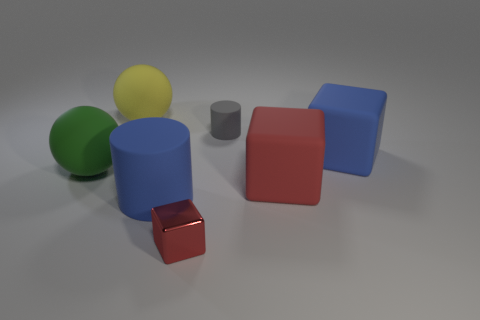Are there any blue matte objects that have the same shape as the tiny metal object?
Ensure brevity in your answer.  Yes. The yellow object that is the same size as the green thing is what shape?
Offer a very short reply. Sphere. What number of big matte cubes are the same color as the metal block?
Give a very brief answer. 1. How big is the blue object that is right of the blue cylinder?
Provide a short and direct response. Large. How many other objects have the same size as the gray object?
Your answer should be very brief. 1. What color is the tiny thing that is the same material as the large blue cube?
Your response must be concise. Gray. Are there fewer matte cylinders right of the big red cube than green cubes?
Provide a short and direct response. No. The red thing that is the same material as the big blue cylinder is what shape?
Your response must be concise. Cube. How many rubber things are red cubes or large gray cubes?
Provide a succinct answer. 1. Are there the same number of large blue things on the right side of the red matte cube and large things?
Keep it short and to the point. No. 